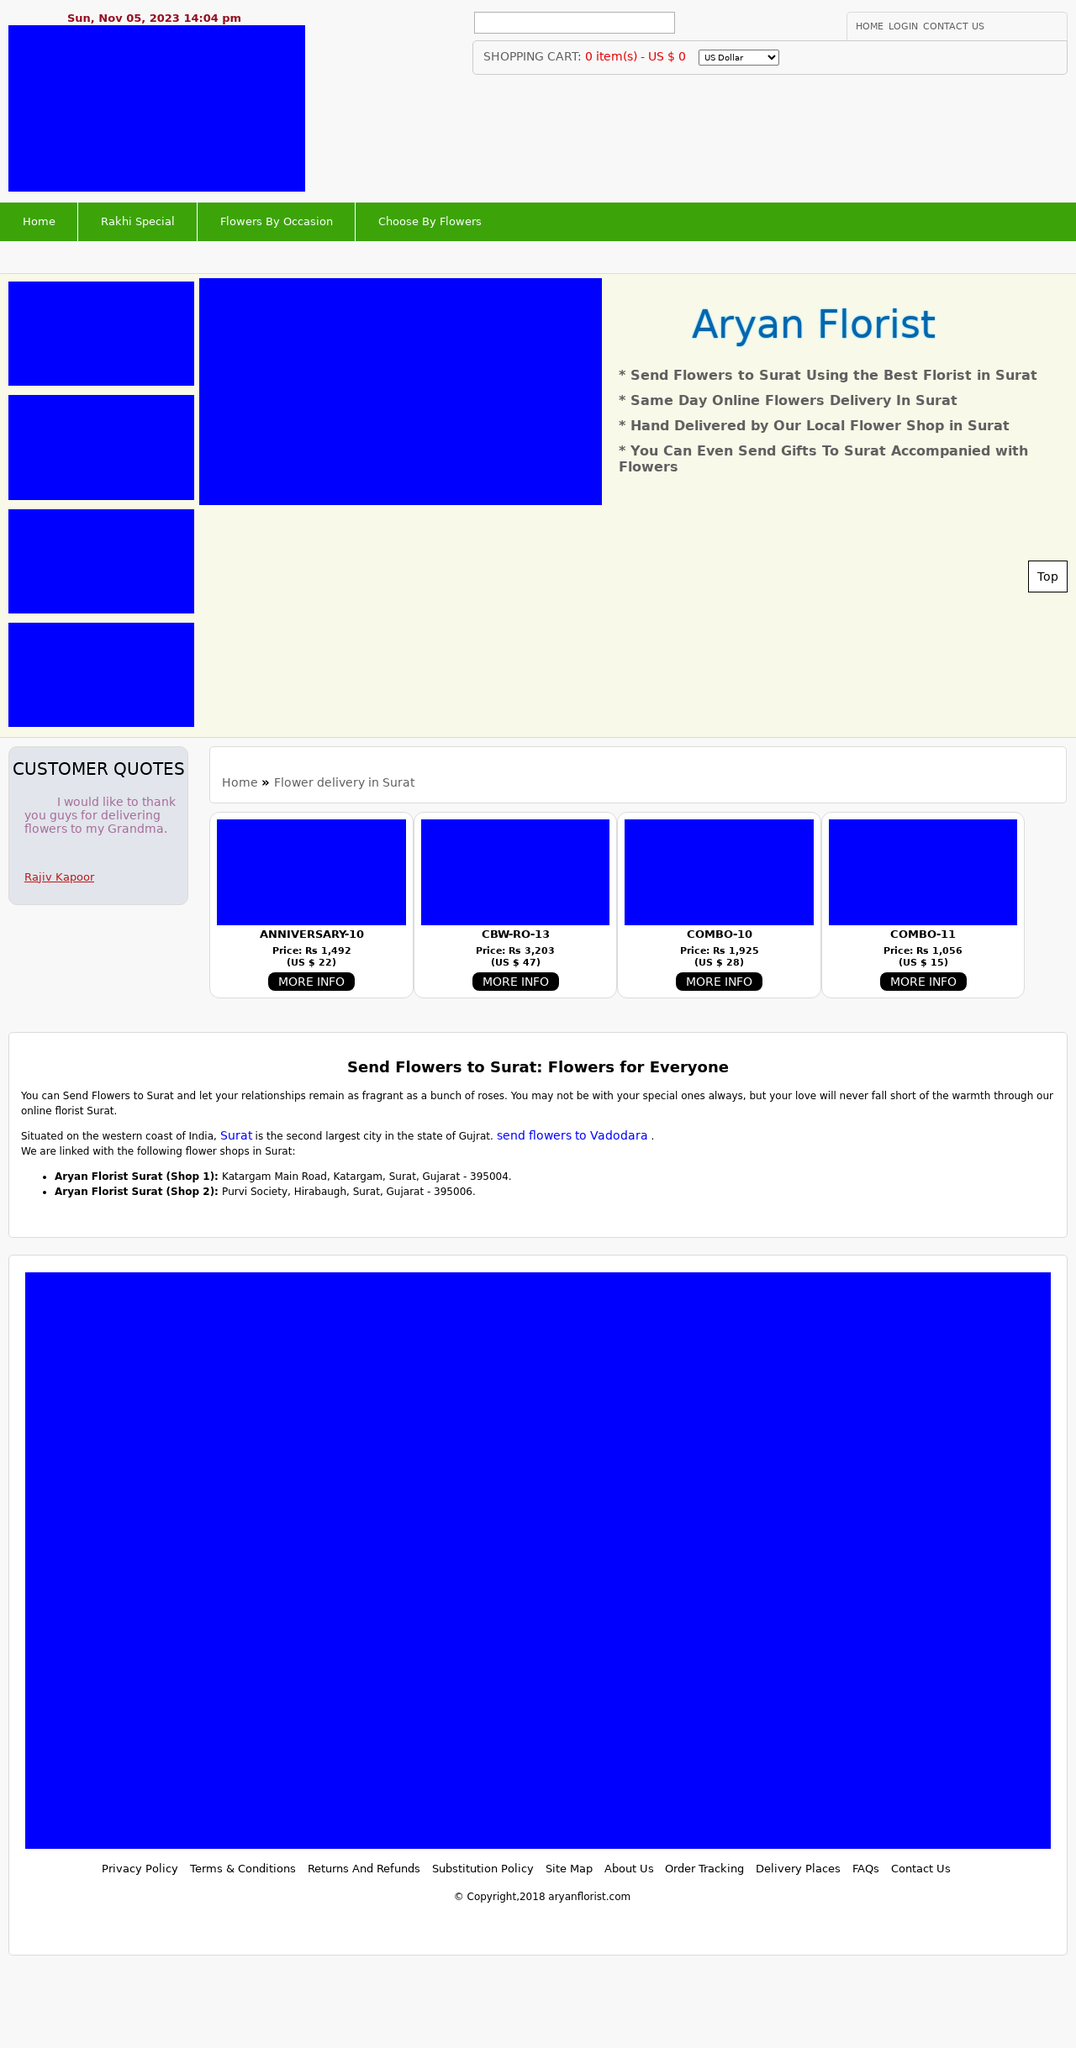What programming languages are essential for creating the functionality of a website such as the one in the image? To create a website similar to the one in the image, you'll need HTML for the structure, CSS for the styling, and JavaScript for interactivity. For backend functions, such as handling forms or dynamic data, languages like PHP, Python, or Node.js are widely used. Additionally, database knowledge, particularly SQL or NoSQL, would be necessary to manage user data and content. 